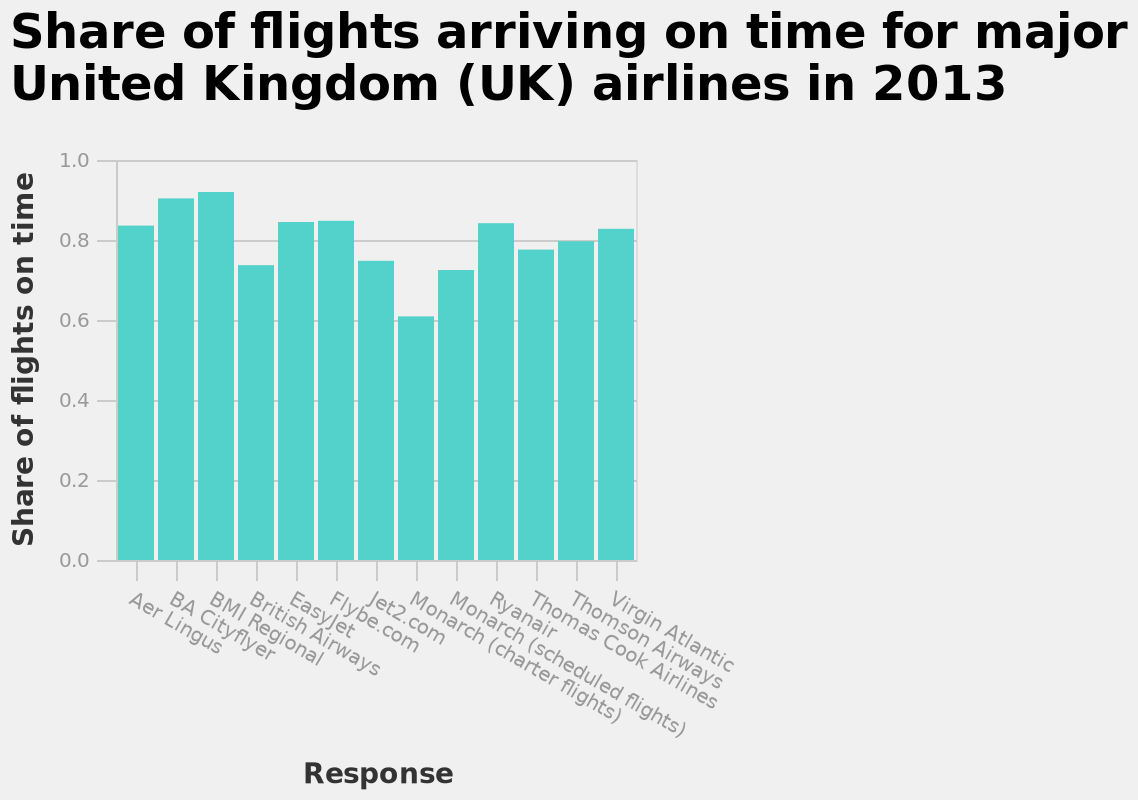<image>
Describe the following image in detail Share of flights arriving on time for major United Kingdom (UK) airlines in 2013 is a bar plot. The x-axis measures Response using categorical scale starting at Aer Lingus and ending at Virgin Atlantic while the y-axis plots Share of flights on time as linear scale with a minimum of 0.0 and a maximum of 1.0. please summary the statistics and relations of the chart BA city flyer had the largest share of on time flights. Monarch charter flights had the smallest share of on time flights. 